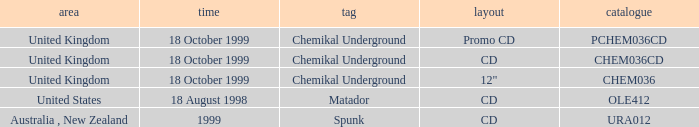What label has a catalog of chem036cd? Chemikal Underground. 